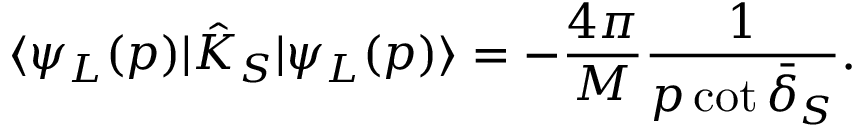Convert formula to latex. <formula><loc_0><loc_0><loc_500><loc_500>\langle \psi _ { L } ( p ) | \hat { K } _ { S } | \psi _ { L } ( p ) \rangle = - \frac { 4 \pi } { M } \frac { 1 } { p \cot \bar { \delta } _ { S } } .</formula> 